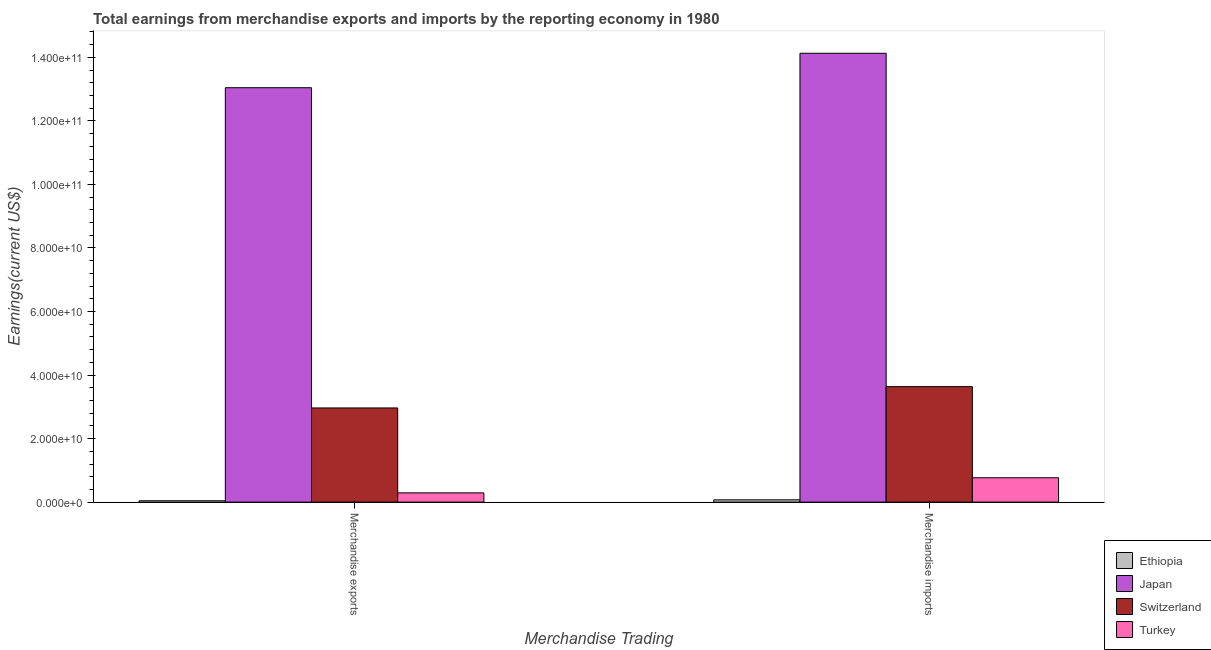How many groups of bars are there?
Keep it short and to the point. 2. Are the number of bars on each tick of the X-axis equal?
Provide a short and direct response. Yes. How many bars are there on the 1st tick from the left?
Ensure brevity in your answer.  4. What is the label of the 1st group of bars from the left?
Your response must be concise. Merchandise exports. What is the earnings from merchandise imports in Turkey?
Your answer should be compact. 7.67e+09. Across all countries, what is the maximum earnings from merchandise exports?
Your answer should be very brief. 1.30e+11. Across all countries, what is the minimum earnings from merchandise exports?
Provide a succinct answer. 4.25e+08. In which country was the earnings from merchandise imports minimum?
Make the answer very short. Ethiopia. What is the total earnings from merchandise exports in the graph?
Give a very brief answer. 1.63e+11. What is the difference between the earnings from merchandise exports in Ethiopia and that in Turkey?
Give a very brief answer. -2.49e+09. What is the difference between the earnings from merchandise imports in Turkey and the earnings from merchandise exports in Ethiopia?
Provide a succinct answer. 7.24e+09. What is the average earnings from merchandise imports per country?
Provide a short and direct response. 4.65e+1. What is the difference between the earnings from merchandise imports and earnings from merchandise exports in Ethiopia?
Provide a short and direct response. 2.97e+08. What is the ratio of the earnings from merchandise exports in Japan to that in Ethiopia?
Give a very brief answer. 307.14. In how many countries, is the earnings from merchandise imports greater than the average earnings from merchandise imports taken over all countries?
Provide a succinct answer. 1. Are all the bars in the graph horizontal?
Your response must be concise. No. What is the difference between two consecutive major ticks on the Y-axis?
Provide a succinct answer. 2.00e+1. Does the graph contain any zero values?
Give a very brief answer. No. Does the graph contain grids?
Provide a succinct answer. No. What is the title of the graph?
Keep it short and to the point. Total earnings from merchandise exports and imports by the reporting economy in 1980. What is the label or title of the X-axis?
Your answer should be very brief. Merchandise Trading. What is the label or title of the Y-axis?
Provide a succinct answer. Earnings(current US$). What is the Earnings(current US$) of Ethiopia in Merchandise exports?
Offer a very short reply. 4.25e+08. What is the Earnings(current US$) in Japan in Merchandise exports?
Make the answer very short. 1.30e+11. What is the Earnings(current US$) in Switzerland in Merchandise exports?
Your answer should be very brief. 2.96e+1. What is the Earnings(current US$) in Turkey in Merchandise exports?
Offer a terse response. 2.91e+09. What is the Earnings(current US$) in Ethiopia in Merchandise imports?
Provide a succinct answer. 7.22e+08. What is the Earnings(current US$) of Japan in Merchandise imports?
Ensure brevity in your answer.  1.41e+11. What is the Earnings(current US$) in Switzerland in Merchandise imports?
Make the answer very short. 3.64e+1. What is the Earnings(current US$) in Turkey in Merchandise imports?
Provide a succinct answer. 7.67e+09. Across all Merchandise Trading, what is the maximum Earnings(current US$) in Ethiopia?
Make the answer very short. 7.22e+08. Across all Merchandise Trading, what is the maximum Earnings(current US$) in Japan?
Make the answer very short. 1.41e+11. Across all Merchandise Trading, what is the maximum Earnings(current US$) in Switzerland?
Offer a very short reply. 3.64e+1. Across all Merchandise Trading, what is the maximum Earnings(current US$) of Turkey?
Ensure brevity in your answer.  7.67e+09. Across all Merchandise Trading, what is the minimum Earnings(current US$) of Ethiopia?
Ensure brevity in your answer.  4.25e+08. Across all Merchandise Trading, what is the minimum Earnings(current US$) in Japan?
Offer a very short reply. 1.30e+11. Across all Merchandise Trading, what is the minimum Earnings(current US$) of Switzerland?
Ensure brevity in your answer.  2.96e+1. Across all Merchandise Trading, what is the minimum Earnings(current US$) in Turkey?
Keep it short and to the point. 2.91e+09. What is the total Earnings(current US$) in Ethiopia in the graph?
Ensure brevity in your answer.  1.15e+09. What is the total Earnings(current US$) in Japan in the graph?
Your response must be concise. 2.72e+11. What is the total Earnings(current US$) of Switzerland in the graph?
Offer a terse response. 6.60e+1. What is the total Earnings(current US$) of Turkey in the graph?
Ensure brevity in your answer.  1.06e+1. What is the difference between the Earnings(current US$) of Ethiopia in Merchandise exports and that in Merchandise imports?
Keep it short and to the point. -2.97e+08. What is the difference between the Earnings(current US$) in Japan in Merchandise exports and that in Merchandise imports?
Your response must be concise. -1.08e+1. What is the difference between the Earnings(current US$) in Switzerland in Merchandise exports and that in Merchandise imports?
Your answer should be very brief. -6.71e+09. What is the difference between the Earnings(current US$) of Turkey in Merchandise exports and that in Merchandise imports?
Offer a very short reply. -4.75e+09. What is the difference between the Earnings(current US$) of Ethiopia in Merchandise exports and the Earnings(current US$) of Japan in Merchandise imports?
Provide a succinct answer. -1.41e+11. What is the difference between the Earnings(current US$) in Ethiopia in Merchandise exports and the Earnings(current US$) in Switzerland in Merchandise imports?
Your answer should be very brief. -3.59e+1. What is the difference between the Earnings(current US$) in Ethiopia in Merchandise exports and the Earnings(current US$) in Turkey in Merchandise imports?
Offer a very short reply. -7.24e+09. What is the difference between the Earnings(current US$) of Japan in Merchandise exports and the Earnings(current US$) of Switzerland in Merchandise imports?
Offer a very short reply. 9.41e+1. What is the difference between the Earnings(current US$) in Japan in Merchandise exports and the Earnings(current US$) in Turkey in Merchandise imports?
Provide a succinct answer. 1.23e+11. What is the difference between the Earnings(current US$) in Switzerland in Merchandise exports and the Earnings(current US$) in Turkey in Merchandise imports?
Ensure brevity in your answer.  2.20e+1. What is the average Earnings(current US$) of Ethiopia per Merchandise Trading?
Provide a succinct answer. 5.73e+08. What is the average Earnings(current US$) of Japan per Merchandise Trading?
Provide a succinct answer. 1.36e+11. What is the average Earnings(current US$) in Switzerland per Merchandise Trading?
Your response must be concise. 3.30e+1. What is the average Earnings(current US$) in Turkey per Merchandise Trading?
Make the answer very short. 5.29e+09. What is the difference between the Earnings(current US$) of Ethiopia and Earnings(current US$) of Japan in Merchandise exports?
Your answer should be compact. -1.30e+11. What is the difference between the Earnings(current US$) of Ethiopia and Earnings(current US$) of Switzerland in Merchandise exports?
Your answer should be compact. -2.92e+1. What is the difference between the Earnings(current US$) of Ethiopia and Earnings(current US$) of Turkey in Merchandise exports?
Offer a terse response. -2.49e+09. What is the difference between the Earnings(current US$) in Japan and Earnings(current US$) in Switzerland in Merchandise exports?
Offer a terse response. 1.01e+11. What is the difference between the Earnings(current US$) of Japan and Earnings(current US$) of Turkey in Merchandise exports?
Offer a very short reply. 1.28e+11. What is the difference between the Earnings(current US$) of Switzerland and Earnings(current US$) of Turkey in Merchandise exports?
Your response must be concise. 2.67e+1. What is the difference between the Earnings(current US$) in Ethiopia and Earnings(current US$) in Japan in Merchandise imports?
Ensure brevity in your answer.  -1.41e+11. What is the difference between the Earnings(current US$) of Ethiopia and Earnings(current US$) of Switzerland in Merchandise imports?
Offer a very short reply. -3.56e+1. What is the difference between the Earnings(current US$) in Ethiopia and Earnings(current US$) in Turkey in Merchandise imports?
Your response must be concise. -6.95e+09. What is the difference between the Earnings(current US$) of Japan and Earnings(current US$) of Switzerland in Merchandise imports?
Offer a very short reply. 1.05e+11. What is the difference between the Earnings(current US$) in Japan and Earnings(current US$) in Turkey in Merchandise imports?
Provide a short and direct response. 1.34e+11. What is the difference between the Earnings(current US$) of Switzerland and Earnings(current US$) of Turkey in Merchandise imports?
Ensure brevity in your answer.  2.87e+1. What is the ratio of the Earnings(current US$) of Ethiopia in Merchandise exports to that in Merchandise imports?
Keep it short and to the point. 0.59. What is the ratio of the Earnings(current US$) of Japan in Merchandise exports to that in Merchandise imports?
Make the answer very short. 0.92. What is the ratio of the Earnings(current US$) in Switzerland in Merchandise exports to that in Merchandise imports?
Provide a short and direct response. 0.82. What is the ratio of the Earnings(current US$) of Turkey in Merchandise exports to that in Merchandise imports?
Give a very brief answer. 0.38. What is the difference between the highest and the second highest Earnings(current US$) of Ethiopia?
Ensure brevity in your answer.  2.97e+08. What is the difference between the highest and the second highest Earnings(current US$) of Japan?
Keep it short and to the point. 1.08e+1. What is the difference between the highest and the second highest Earnings(current US$) of Switzerland?
Offer a terse response. 6.71e+09. What is the difference between the highest and the second highest Earnings(current US$) of Turkey?
Give a very brief answer. 4.75e+09. What is the difference between the highest and the lowest Earnings(current US$) in Ethiopia?
Your response must be concise. 2.97e+08. What is the difference between the highest and the lowest Earnings(current US$) of Japan?
Your answer should be very brief. 1.08e+1. What is the difference between the highest and the lowest Earnings(current US$) of Switzerland?
Your answer should be very brief. 6.71e+09. What is the difference between the highest and the lowest Earnings(current US$) of Turkey?
Keep it short and to the point. 4.75e+09. 